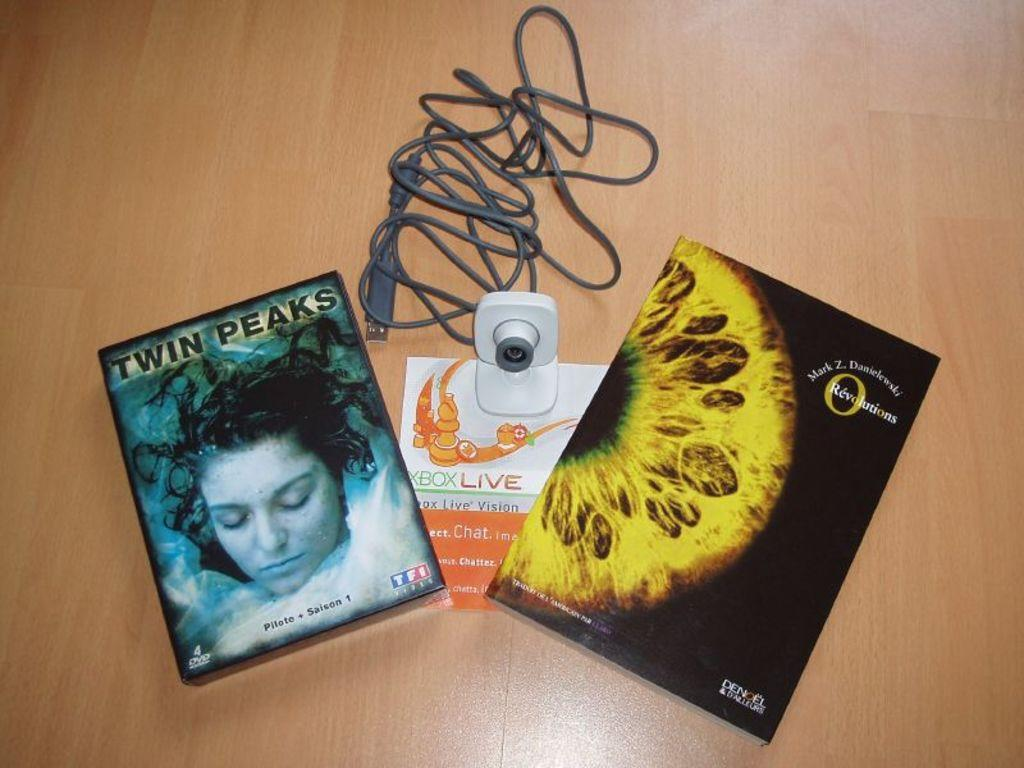What is the main subject in the center of the image? There are covers with text in the center of the image. What device can be seen in the image? There is a camera in the image. What material is the wire resting on in the image? The wire is on a wooden surface in the image. What type of breakfast is being prepared in the image? There is no breakfast preparation visible in the image. What type of loss is depicted in the image? There is no loss depicted in the image. 